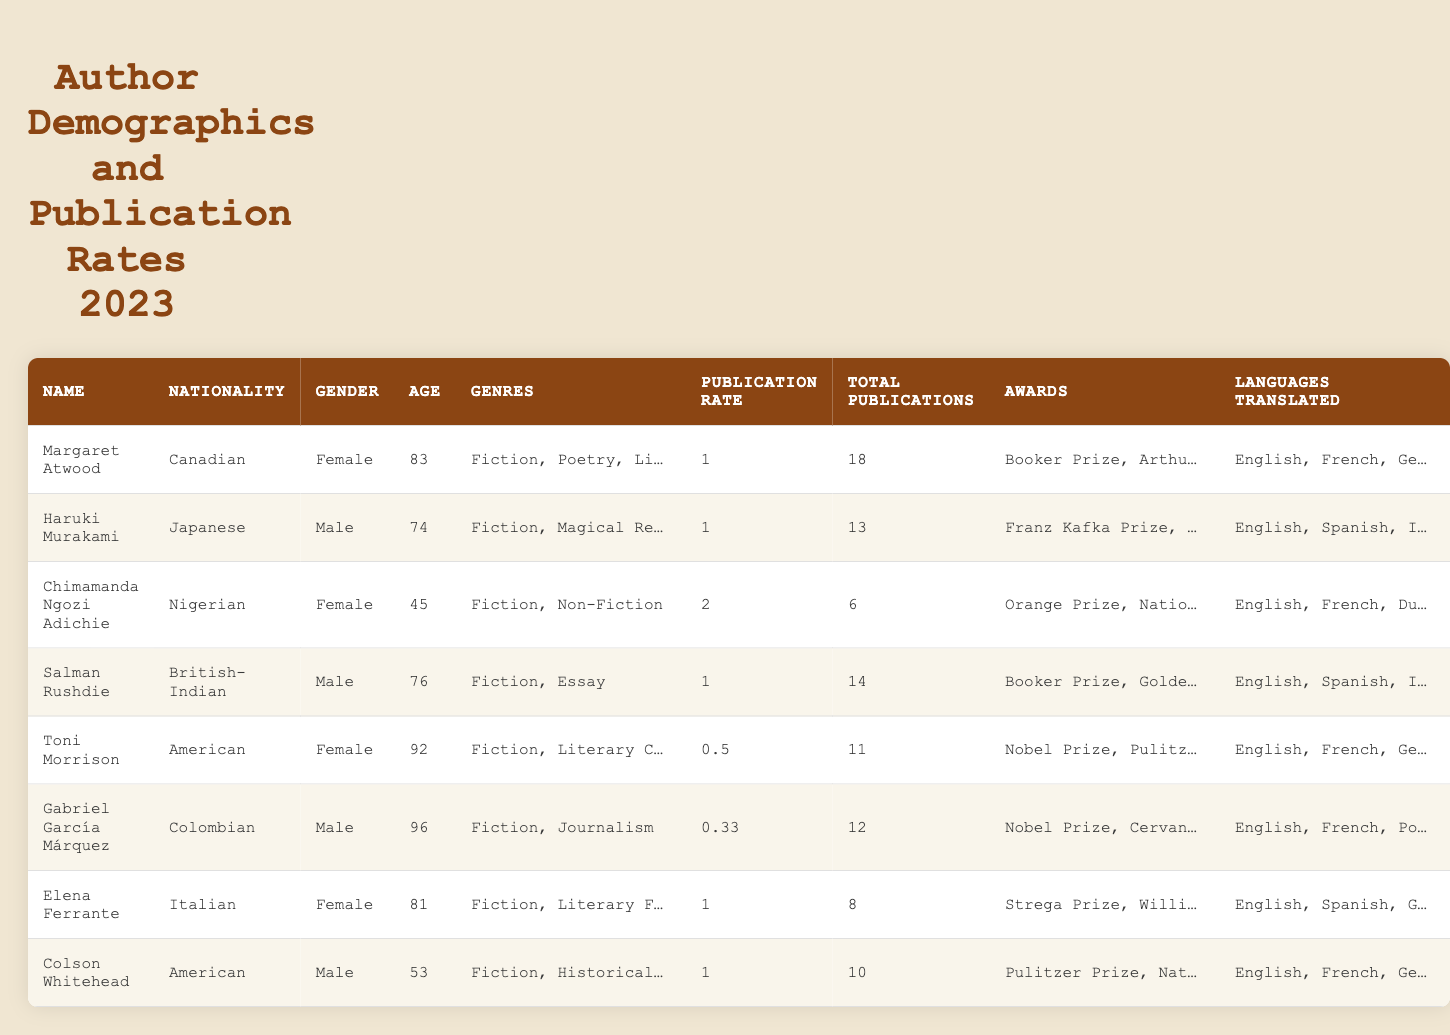What is the nationality of Gabriel García Márquez? The table lists Gabriel García Márquez's nationality directly as Colombian.
Answer: Colombian Which author has the highest publication rate? By examining the publication rates listed in the table, Chimamanda Ngozi Adichie has the highest publication rate at 2.
Answer: Chimamanda Ngozi Adichie How many total publications does Haruki Murakami have? The table states that Haruki Murakami has a total of 13 publications.
Answer: 13 Is there an author who has won both the Booker Prize and the Nobel Prize? The table shows that both Salman Rushdie and Toni Morrison have won the Booker Prize, and Toni Morrison has additionally won the Nobel Prize. Thus, the statement is true.
Answer: Yes Which female author has the most publications? By comparing the total publications of female authors from the table, Margaret Atwood has the most with 18 publications.
Answer: Margaret Atwood What is the average publication rate of the authors listed? To find the average, sum all publication rates (1 + 1 + 2 + 1 + 0.5 + 0.33 + 1 + 1) = 7.83. Then, divide by 8 (the number of authors) to get 7.83 / 8 = 0.98.
Answer: 0.98 Which author has published more than 10 works and is male? The table shows that both Salman Rushdie (14 publications) and Colson Whitehead (10 publications) are male authors with a total of more than 10 works published.
Answer: Salman Rushdie, Colson Whitehead What are the genres of Elana Ferrante? According to the table, Elena Ferrante writes in the genres of Fiction and Literary Fiction.
Answer: Fiction, Literary Fiction How many languages can Toni Morrison's works be translated into? The table lists three languages (English, French, German) for Toni Morrison, indicating her works can be translated into these languages.
Answer: 3 Who is the youngest author in the table? By comparing the ages listed, Chimamanda Ngozi Adichie is the youngest at 45 years old.
Answer: Chimamanda Ngozi Adichie What is the difference in total publications between Margaret Atwood and Gabriel García Márquez? Margaret Atwood has 18 total publications; Gabriel García Márquez has 12. The difference is 18 - 12 = 6.
Answer: 6 